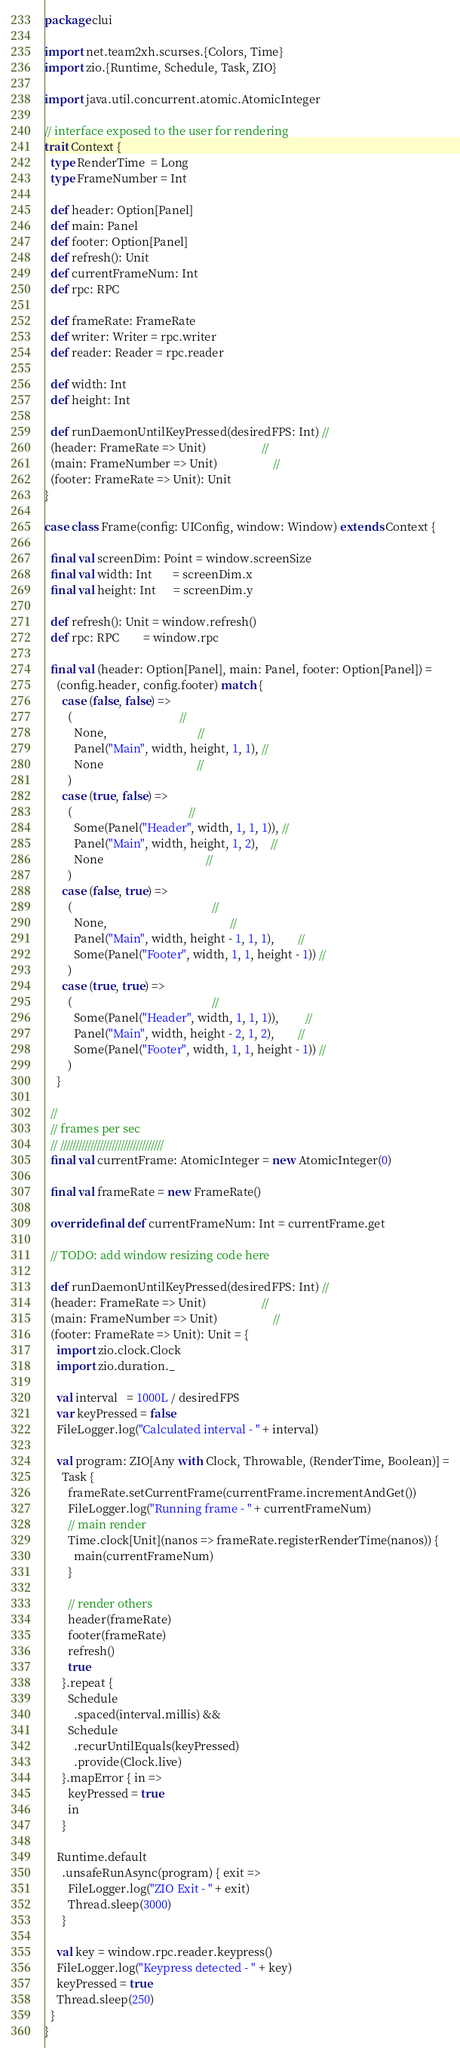<code> <loc_0><loc_0><loc_500><loc_500><_Scala_>package clui

import net.team2xh.scurses.{Colors, Time}
import zio.{Runtime, Schedule, Task, ZIO}

import java.util.concurrent.atomic.AtomicInteger

// interface exposed to the user for rendering
trait Context {
  type RenderTime  = Long
  type FrameNumber = Int

  def header: Option[Panel]
  def main: Panel
  def footer: Option[Panel]
  def refresh(): Unit
  def currentFrameNum: Int
  def rpc: RPC

  def frameRate: FrameRate
  def writer: Writer = rpc.writer
  def reader: Reader = rpc.reader

  def width: Int
  def height: Int

  def runDaemonUntilKeyPressed(desiredFPS: Int) //
  (header: FrameRate => Unit)                   //
  (main: FrameNumber => Unit)                   //
  (footer: FrameRate => Unit): Unit
}

case class Frame(config: UIConfig, window: Window) extends Context {

  final val screenDim: Point = window.screenSize
  final val width: Int       = screenDim.x
  final val height: Int      = screenDim.y

  def refresh(): Unit = window.refresh()
  def rpc: RPC        = window.rpc

  final val (header: Option[Panel], main: Panel, footer: Option[Panel]) =
    (config.header, config.footer) match {
      case (false, false) =>
        (                                     //
          None,                               //
          Panel("Main", width, height, 1, 1), //
          None                                //
        )
      case (true, false) =>
        (                                        //
          Some(Panel("Header", width, 1, 1, 1)), //
          Panel("Main", width, height, 1, 2),    //
          None                                   //
        )
      case (false, true) =>
        (                                                //
          None,                                          //
          Panel("Main", width, height - 1, 1, 1),        //
          Some(Panel("Footer", width, 1, 1, height - 1)) //
        )
      case (true, true) =>
        (                                                //
          Some(Panel("Header", width, 1, 1, 1)),         //
          Panel("Main", width, height - 2, 1, 2),        //
          Some(Panel("Footer", width, 1, 1, height - 1)) //
        )
    }

  //
  // frames per sec
  // //////////////////////////////////
  final val currentFrame: AtomicInteger = new AtomicInteger(0)

  final val frameRate = new FrameRate()

  override final def currentFrameNum: Int = currentFrame.get

  // TODO: add window resizing code here

  def runDaemonUntilKeyPressed(desiredFPS: Int) //
  (header: FrameRate => Unit)                   //
  (main: FrameNumber => Unit)                   //
  (footer: FrameRate => Unit): Unit = {
    import zio.clock.Clock
    import zio.duration._

    val interval   = 1000L / desiredFPS
    var keyPressed = false
    FileLogger.log("Calculated interval - " + interval)

    val program: ZIO[Any with Clock, Throwable, (RenderTime, Boolean)] =
      Task {
        frameRate.setCurrentFrame(currentFrame.incrementAndGet())
        FileLogger.log("Running frame - " + currentFrameNum)
        // main render
        Time.clock[Unit](nanos => frameRate.registerRenderTime(nanos)) {
          main(currentFrameNum)
        }

        // render others
        header(frameRate)
        footer(frameRate)
        refresh()
        true
      }.repeat {
        Schedule
          .spaced(interval.millis) &&
        Schedule
          .recurUntilEquals(keyPressed)
          .provide(Clock.live)
      }.mapError { in =>
        keyPressed = true
        in
      }

    Runtime.default
      .unsafeRunAsync(program) { exit =>
        FileLogger.log("ZIO Exit - " + exit)
        Thread.sleep(3000)
      }

    val key = window.rpc.reader.keypress()
    FileLogger.log("Keypress detected - " + key)
    keyPressed = true
    Thread.sleep(250)
  }
}
</code> 